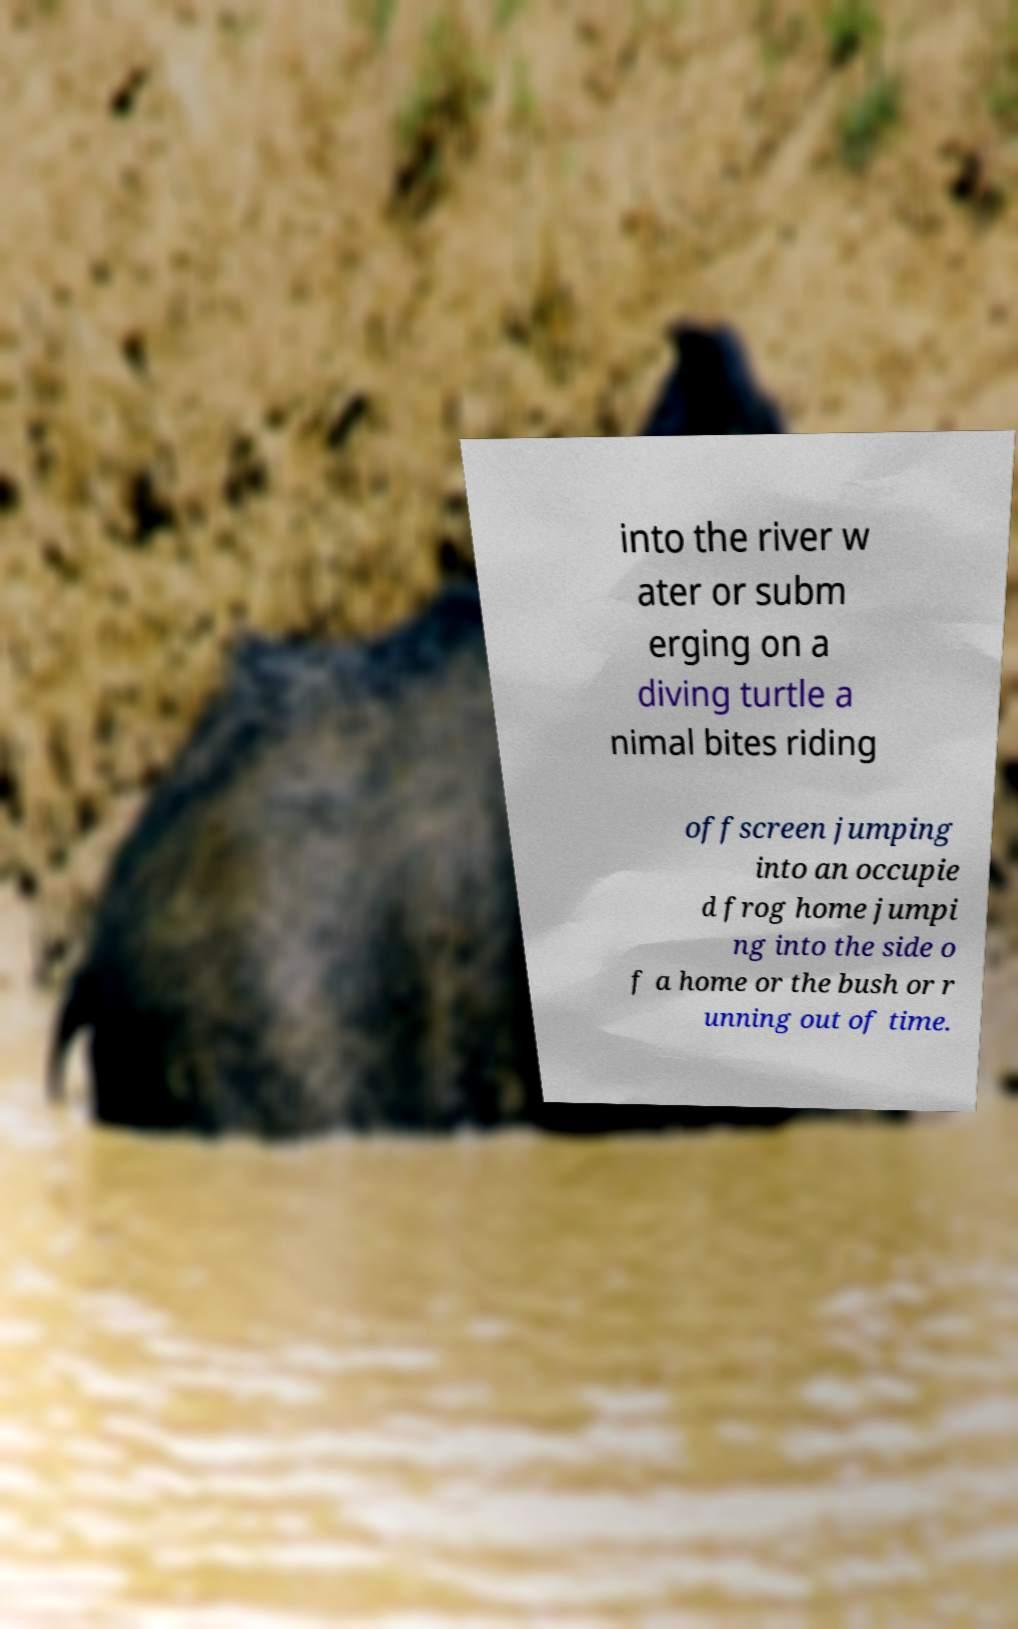What messages or text are displayed in this image? I need them in a readable, typed format. into the river w ater or subm erging on a diving turtle a nimal bites riding offscreen jumping into an occupie d frog home jumpi ng into the side o f a home or the bush or r unning out of time. 